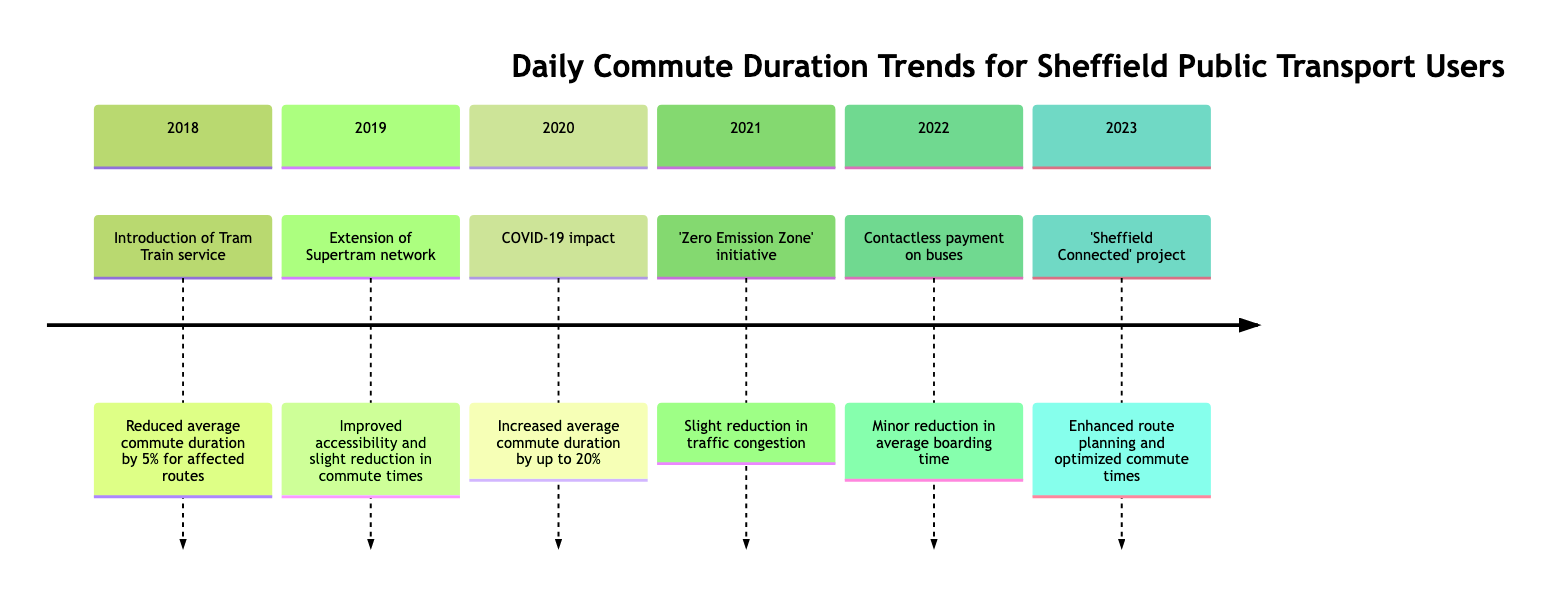What was the impact of the Tram Train service introduction in 2018? The introduction of the Tram Train service in 2018 reduced the average commute duration by 5% for affected routes, indicating a positive effect on travel times for those using this new option.
Answer: Reduced average commute duration by 5% What major event affected public transport usage in 2020? The COVID-19 pandemic significantly impacted public transport usage in 2020, as reflected in the timeline which states it resulted in reduced service frequency and social distancing measures leading to longer waiting times.
Answer: COVID-19 pandemic Did the 'Zero Emission Zone' initiative in 2021 help bus users? Yes, the 'Zero Emission Zone' initiative helped bus users as it led to a slight reduction in traffic congestion, which contributed to marginally faster commute times for those using buses.
Answer: Yes How much did the average commute duration increase in 2020? The average commute duration increased by up to 20% in 2020 due to the impacts of the COVID-19 pandemic, which included longer waiting times as a result of reduced service availability.
Answer: Up to 20% What change occurred in 2022 related to payment systems? In 2022, contactless payment systems were introduced on buses, which made the boarding process faster and more efficient, leading to a minor reduction in average boarding time and slight improvement in overall commute duration.
Answer: Contactless payment systems on buses What project was launched in 2023 to enhance public transport? The 'Sheffield Connected' project was launched in 2023 with a focus on real-time tracking and integrated public transport planning apps, aiming to optimize commute times for users through better route planning.
Answer: 'Sheffield Connected' project How did the extension of the Supertram network in 2019 affect commuters? The extension of the Supertram network in 2019 improved accessibility in new residential areas and resulted in a slight reduction in commute times, benefiting residents in those regions.
Answer: Slight reduction in commute times What is the primary theme of the timeline? The primary theme of the timeline revolves around the trends of daily commute durations for public transport users in Sheffield, showcasing various events and their impacts on travel times.
Answer: Daily Commute Duration Trends for Sheffield Public Transport Users What was a notable impact of the contactless payment introduction? The introduction of contactless payment systems in 2022 resulted in a minor reduction in average boarding time, which contributed to an improvement in overall commute durations for users.
Answer: Minor reduction in average boarding time 